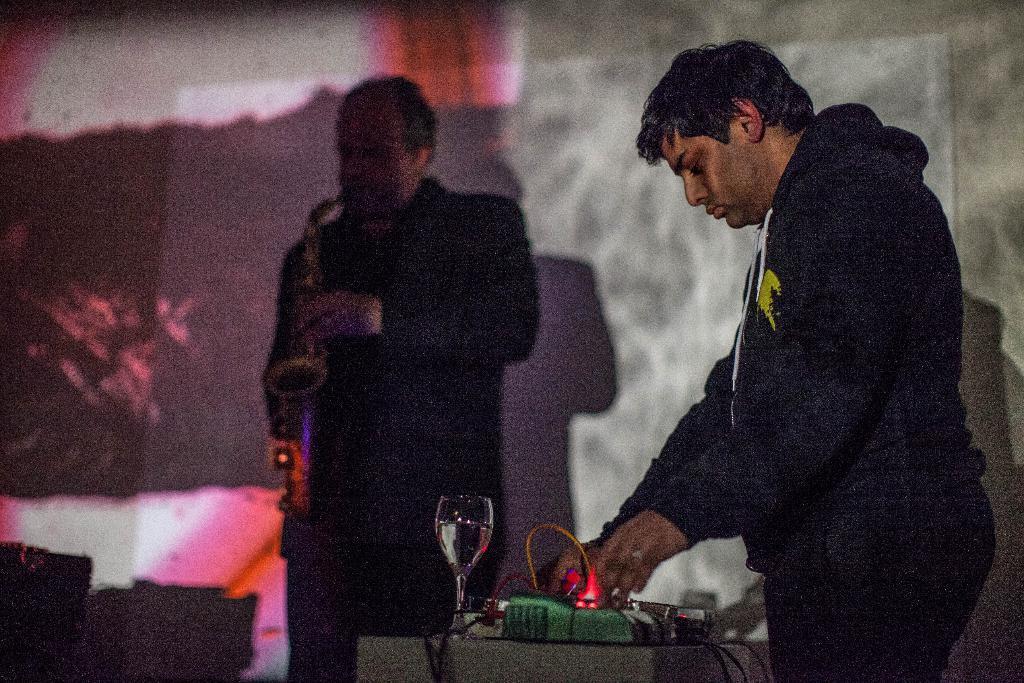Could you give a brief overview of what you see in this image? In this image we can see a person standing on the right side of the image and in front of him there is a table with some objects. In the background, we can see a person standing and playing musical instrument. 